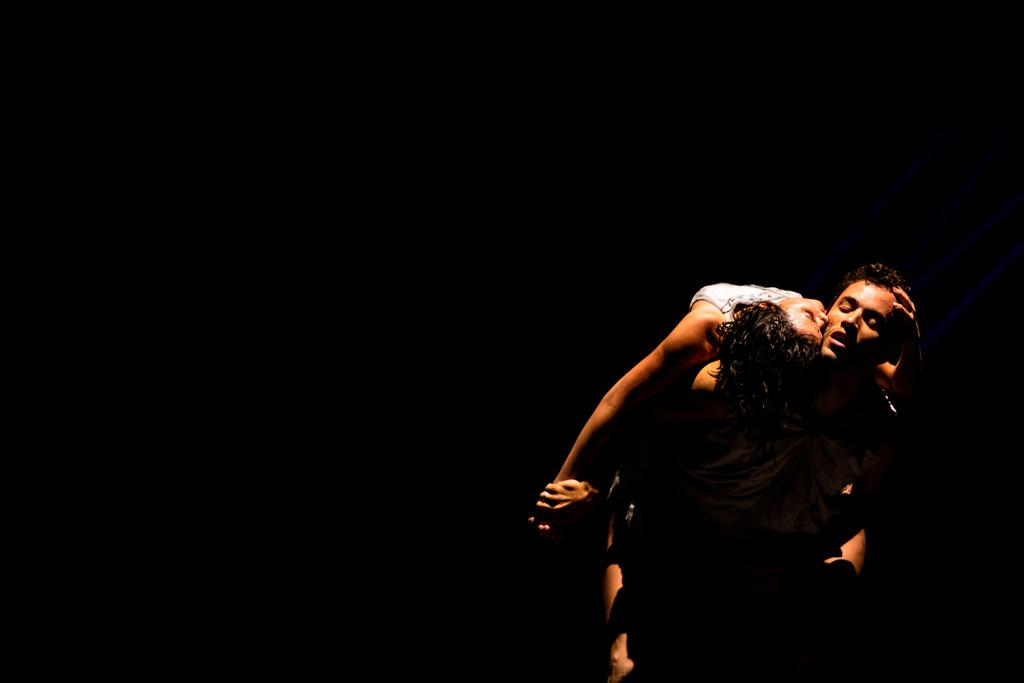How many individuals are present in the image? There are two people in the image. What can be observed about the background of the image? The background of the image is dark. What type of magic is being performed by the committee in the image? There is no committee or magic present in the image; it features two people with a dark background. 